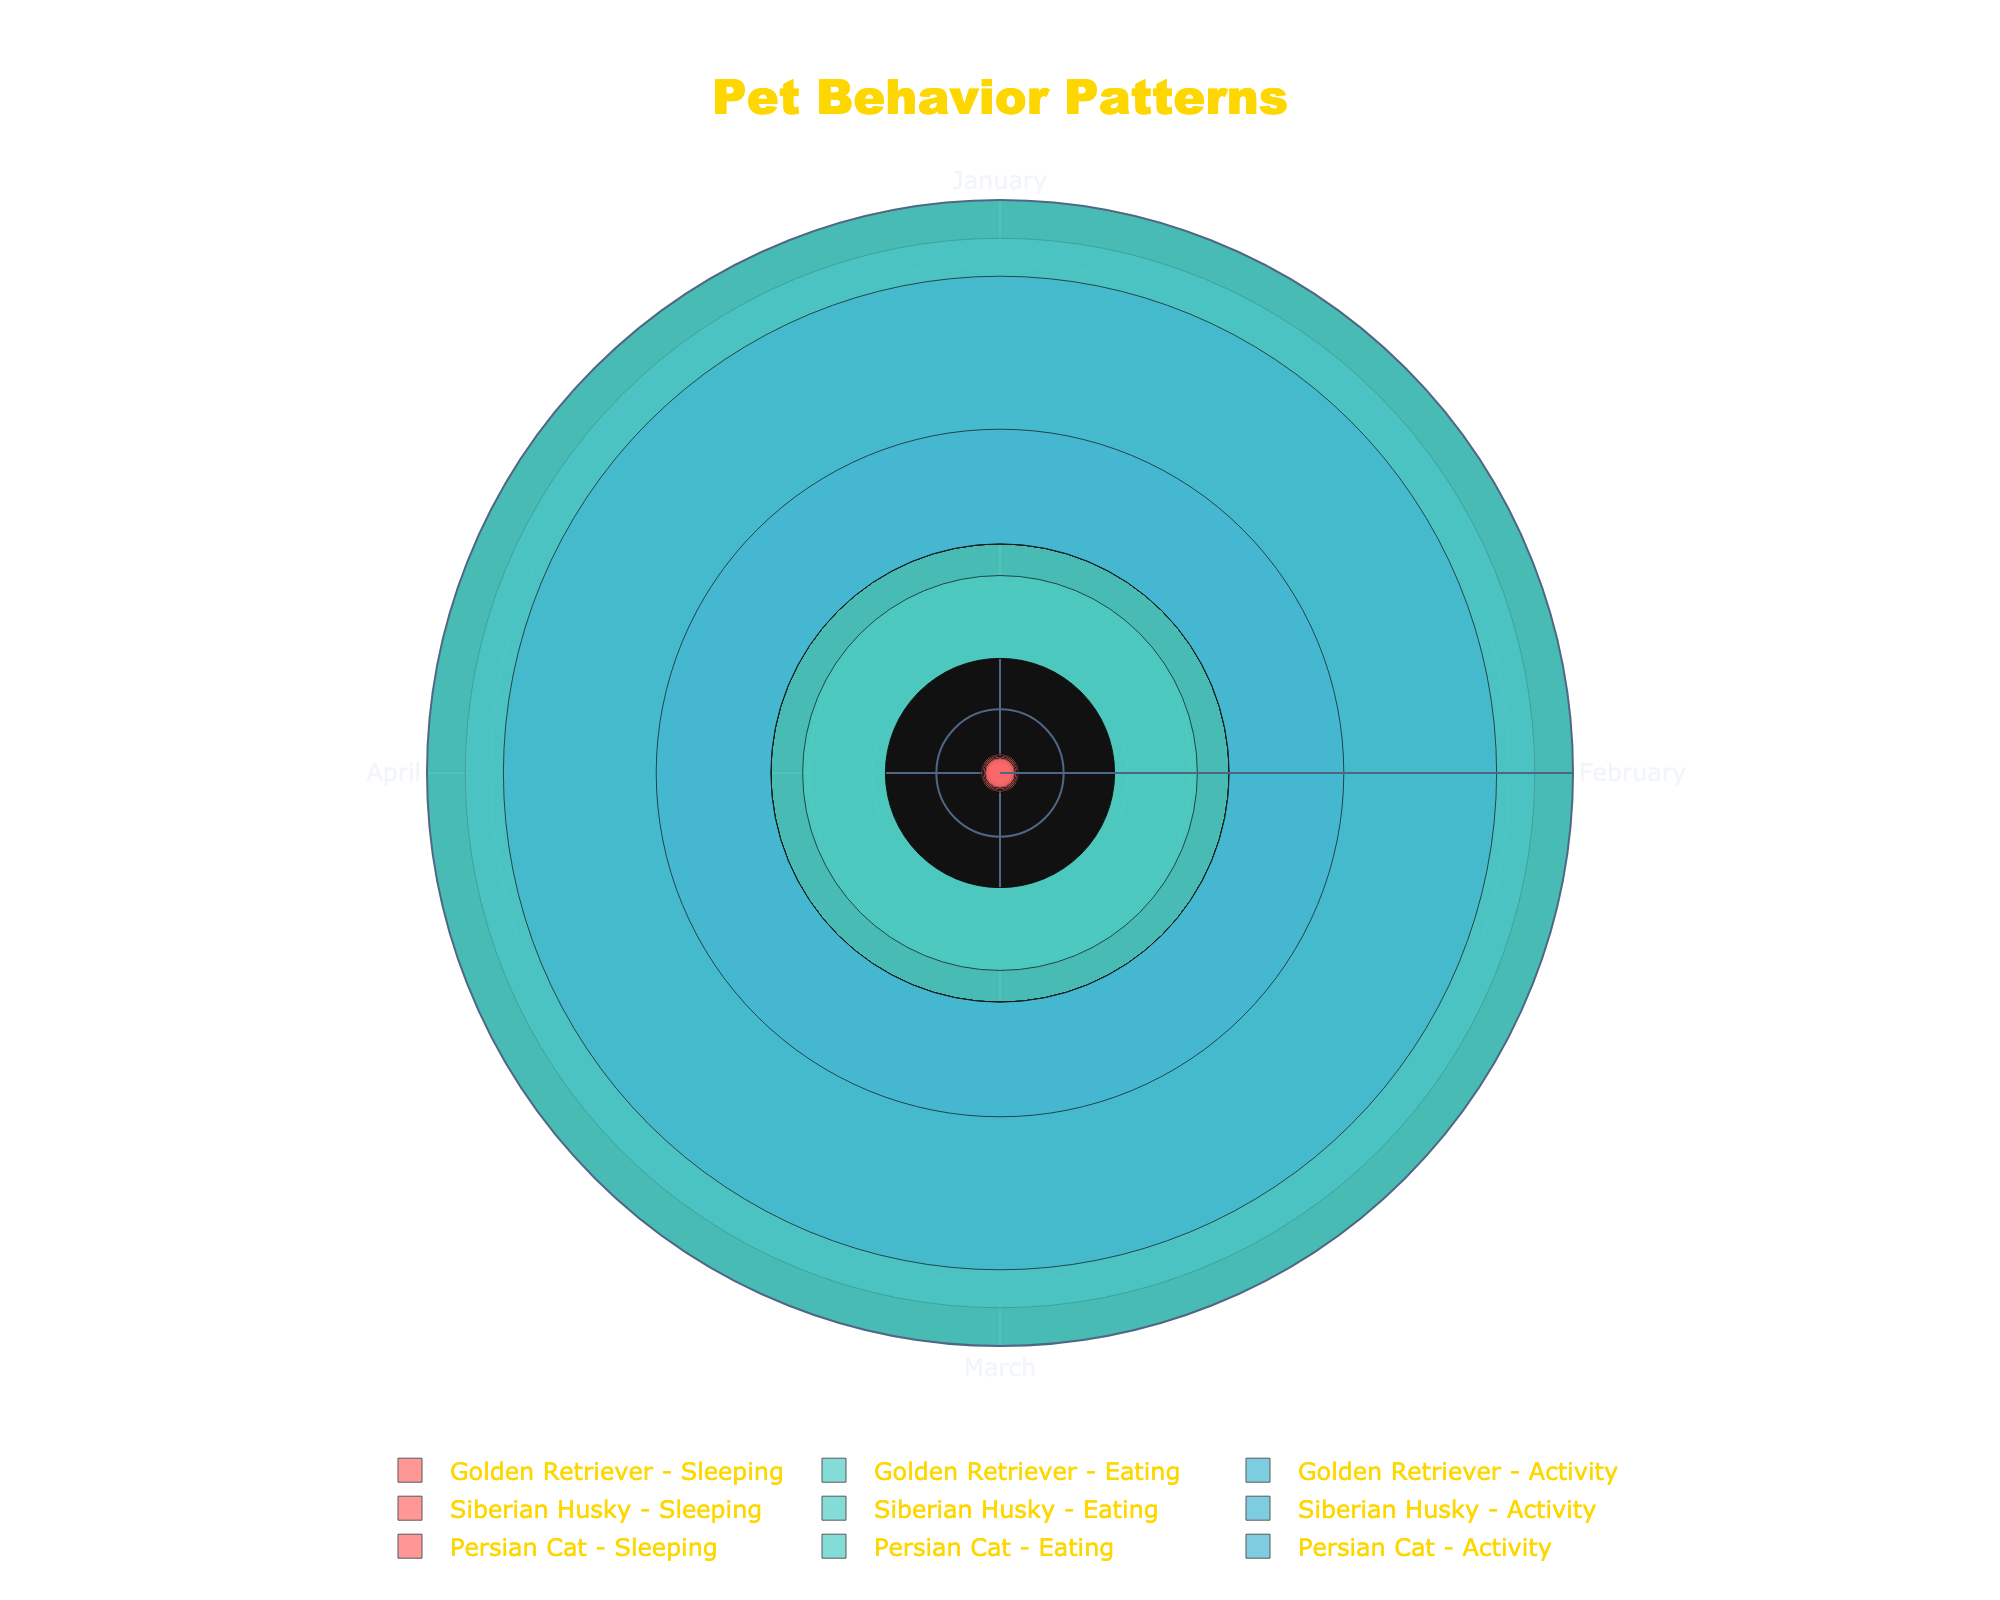What title is given to the rose chart? The title is usually located at the top center of the plot. To find it, look at the specified location and read the text there.
Answer: Pet Behavior Patterns How many breeds are displayed in the chart? The legend at the bottom of the chart shows the different breeds. Count the unique breed names listed.
Answer: 3 What color represents the eating behavior? Each behavior is represented by a different color, as shown in the legend. Identify the color next to "Eating" in the legend.
Answer: Turquoise During which month do Golden Retrievers have the highest activity level? Identify the bars labeled "Golden Retriever - Activity" and compare the lengths of these bars across the months. The longest bar indicates the highest activity level.
Answer: April How many hours does the Persian Cat sleep in March? Locate the "Persian Cat - Sleeping" bar for March and check the corresponding value (height of the bar) for the sleeping hours.
Answer: 13 hours What is the total amount of food eaten by the Siberian Husky from January to April? For the "Siberian Husky - Eating" bars, sum the quantities for each month: January (350g), February (360g), March (370g), and April (380g). Add these values together.
Answer: 1460g Which breed shows the least activity in January? Compare the heights of the "Activity" bars for January across all breeds. The shortest bar represents the breed with the least activity.
Answer: Persian Cat How does the activity level of the Siberian Husky in February compare to that in March? Locate the "Siberian Husky - Activity" bars for February and March, then compare their heights. The difference can be observed by noting how much taller or shorter one is compared to the other.
Answer: Activity increases from 170 minutes in February to 190 minutes in March, a 20-minute increase Which behavior pattern shows the most consistent increase for Golden Retrievers over the months? Compare the change in the heights of the "Golden Retriever" bars for each behavior (Sleeping, Eating, Activity) from January to April. Identify the behavior with a steady increase.
Answer: Activity What is the difference in food consumption between Golden Retrievers and Persian Cats in January? Locate the "Eating" bar for "Golden Retrievers" and "Persian Cats" in January, then subtract the Persian Cat's value from the Golden Retriever's value. Golden Retriever (400g) - Persian Cat (50g) = 350g.
Answer: 350g 